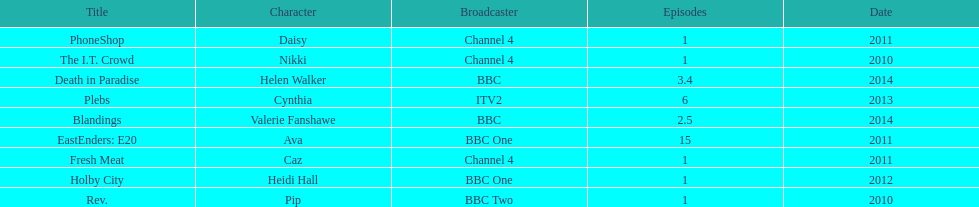Which broadcaster hosted 3 titles but they had only 1 episode? Channel 4. 